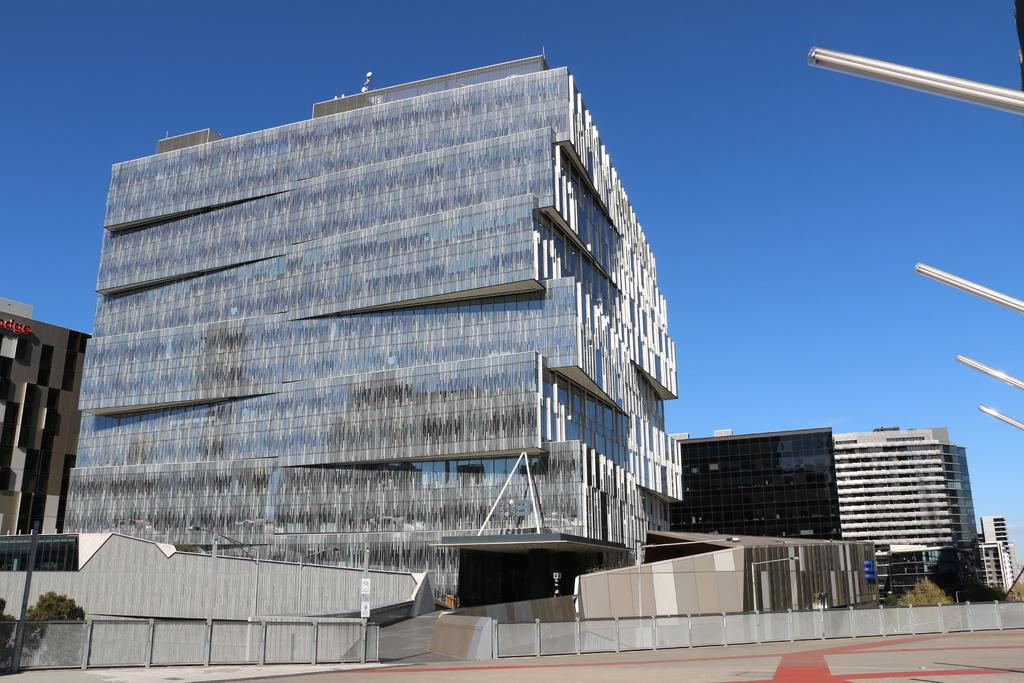What type of structures can be seen in the image? There are buildings in the image. What other natural elements are present in the image? There are trees in the image. What type of barrier can be seen in the image? There is a fence in the image. What is visible in the background of the image? The sky is visible in the background of the image. What is the acoustics like in the lake shown in the image? There is no lake present in the image, so it is not possible to determine the acoustics in a lake. 